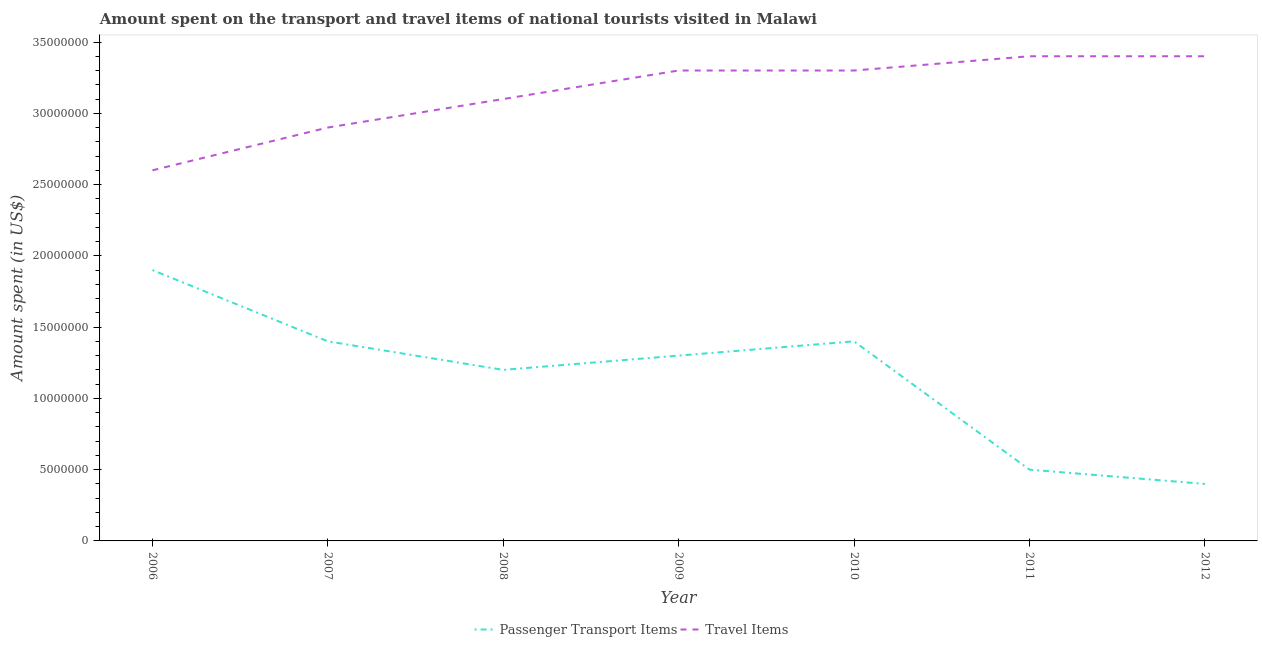Does the line corresponding to amount spent in travel items intersect with the line corresponding to amount spent on passenger transport items?
Offer a terse response. No. What is the amount spent in travel items in 2011?
Your response must be concise. 3.40e+07. Across all years, what is the maximum amount spent in travel items?
Keep it short and to the point. 3.40e+07. Across all years, what is the minimum amount spent on passenger transport items?
Keep it short and to the point. 4.00e+06. In which year was the amount spent in travel items minimum?
Provide a succinct answer. 2006. What is the total amount spent in travel items in the graph?
Your answer should be compact. 2.20e+08. What is the difference between the amount spent on passenger transport items in 2010 and that in 2011?
Provide a succinct answer. 9.00e+06. What is the difference between the amount spent in travel items in 2012 and the amount spent on passenger transport items in 2007?
Your response must be concise. 2.00e+07. What is the average amount spent in travel items per year?
Keep it short and to the point. 3.14e+07. In the year 2009, what is the difference between the amount spent in travel items and amount spent on passenger transport items?
Provide a short and direct response. 2.00e+07. In how many years, is the amount spent in travel items greater than 19000000 US$?
Offer a terse response. 7. What is the ratio of the amount spent in travel items in 2006 to that in 2007?
Ensure brevity in your answer.  0.9. Is the difference between the amount spent in travel items in 2009 and 2010 greater than the difference between the amount spent on passenger transport items in 2009 and 2010?
Your response must be concise. Yes. What is the difference between the highest and the lowest amount spent on passenger transport items?
Ensure brevity in your answer.  1.50e+07. Is the sum of the amount spent in travel items in 2009 and 2012 greater than the maximum amount spent on passenger transport items across all years?
Keep it short and to the point. Yes. Is the amount spent on passenger transport items strictly greater than the amount spent in travel items over the years?
Make the answer very short. No. Is the amount spent in travel items strictly less than the amount spent on passenger transport items over the years?
Ensure brevity in your answer.  No. Are the values on the major ticks of Y-axis written in scientific E-notation?
Your response must be concise. No. Where does the legend appear in the graph?
Provide a short and direct response. Bottom center. How are the legend labels stacked?
Your response must be concise. Horizontal. What is the title of the graph?
Offer a terse response. Amount spent on the transport and travel items of national tourists visited in Malawi. What is the label or title of the Y-axis?
Offer a very short reply. Amount spent (in US$). What is the Amount spent (in US$) in Passenger Transport Items in 2006?
Make the answer very short. 1.90e+07. What is the Amount spent (in US$) of Travel Items in 2006?
Make the answer very short. 2.60e+07. What is the Amount spent (in US$) of Passenger Transport Items in 2007?
Your response must be concise. 1.40e+07. What is the Amount spent (in US$) of Travel Items in 2007?
Offer a terse response. 2.90e+07. What is the Amount spent (in US$) of Passenger Transport Items in 2008?
Provide a succinct answer. 1.20e+07. What is the Amount spent (in US$) of Travel Items in 2008?
Your answer should be very brief. 3.10e+07. What is the Amount spent (in US$) in Passenger Transport Items in 2009?
Give a very brief answer. 1.30e+07. What is the Amount spent (in US$) of Travel Items in 2009?
Keep it short and to the point. 3.30e+07. What is the Amount spent (in US$) in Passenger Transport Items in 2010?
Ensure brevity in your answer.  1.40e+07. What is the Amount spent (in US$) of Travel Items in 2010?
Offer a very short reply. 3.30e+07. What is the Amount spent (in US$) in Travel Items in 2011?
Give a very brief answer. 3.40e+07. What is the Amount spent (in US$) of Travel Items in 2012?
Ensure brevity in your answer.  3.40e+07. Across all years, what is the maximum Amount spent (in US$) of Passenger Transport Items?
Ensure brevity in your answer.  1.90e+07. Across all years, what is the maximum Amount spent (in US$) of Travel Items?
Ensure brevity in your answer.  3.40e+07. Across all years, what is the minimum Amount spent (in US$) of Passenger Transport Items?
Make the answer very short. 4.00e+06. Across all years, what is the minimum Amount spent (in US$) in Travel Items?
Your response must be concise. 2.60e+07. What is the total Amount spent (in US$) in Passenger Transport Items in the graph?
Your answer should be compact. 8.10e+07. What is the total Amount spent (in US$) of Travel Items in the graph?
Your answer should be very brief. 2.20e+08. What is the difference between the Amount spent (in US$) in Travel Items in 2006 and that in 2007?
Your answer should be compact. -3.00e+06. What is the difference between the Amount spent (in US$) of Passenger Transport Items in 2006 and that in 2008?
Make the answer very short. 7.00e+06. What is the difference between the Amount spent (in US$) in Travel Items in 2006 and that in 2008?
Your answer should be compact. -5.00e+06. What is the difference between the Amount spent (in US$) in Travel Items in 2006 and that in 2009?
Provide a short and direct response. -7.00e+06. What is the difference between the Amount spent (in US$) in Travel Items in 2006 and that in 2010?
Offer a terse response. -7.00e+06. What is the difference between the Amount spent (in US$) of Passenger Transport Items in 2006 and that in 2011?
Your answer should be compact. 1.40e+07. What is the difference between the Amount spent (in US$) in Travel Items in 2006 and that in 2011?
Keep it short and to the point. -8.00e+06. What is the difference between the Amount spent (in US$) in Passenger Transport Items in 2006 and that in 2012?
Make the answer very short. 1.50e+07. What is the difference between the Amount spent (in US$) of Travel Items in 2006 and that in 2012?
Your response must be concise. -8.00e+06. What is the difference between the Amount spent (in US$) of Passenger Transport Items in 2007 and that in 2009?
Your answer should be very brief. 1.00e+06. What is the difference between the Amount spent (in US$) of Travel Items in 2007 and that in 2009?
Provide a succinct answer. -4.00e+06. What is the difference between the Amount spent (in US$) of Passenger Transport Items in 2007 and that in 2010?
Provide a short and direct response. 0. What is the difference between the Amount spent (in US$) in Passenger Transport Items in 2007 and that in 2011?
Provide a succinct answer. 9.00e+06. What is the difference between the Amount spent (in US$) in Travel Items in 2007 and that in 2011?
Keep it short and to the point. -5.00e+06. What is the difference between the Amount spent (in US$) of Travel Items in 2007 and that in 2012?
Provide a succinct answer. -5.00e+06. What is the difference between the Amount spent (in US$) of Passenger Transport Items in 2008 and that in 2010?
Your answer should be very brief. -2.00e+06. What is the difference between the Amount spent (in US$) of Passenger Transport Items in 2008 and that in 2011?
Your answer should be very brief. 7.00e+06. What is the difference between the Amount spent (in US$) in Travel Items in 2008 and that in 2011?
Ensure brevity in your answer.  -3.00e+06. What is the difference between the Amount spent (in US$) in Passenger Transport Items in 2008 and that in 2012?
Ensure brevity in your answer.  8.00e+06. What is the difference between the Amount spent (in US$) in Travel Items in 2009 and that in 2010?
Provide a succinct answer. 0. What is the difference between the Amount spent (in US$) of Passenger Transport Items in 2009 and that in 2011?
Offer a very short reply. 8.00e+06. What is the difference between the Amount spent (in US$) in Passenger Transport Items in 2009 and that in 2012?
Give a very brief answer. 9.00e+06. What is the difference between the Amount spent (in US$) of Passenger Transport Items in 2010 and that in 2011?
Provide a short and direct response. 9.00e+06. What is the difference between the Amount spent (in US$) in Travel Items in 2010 and that in 2011?
Offer a very short reply. -1.00e+06. What is the difference between the Amount spent (in US$) of Travel Items in 2010 and that in 2012?
Give a very brief answer. -1.00e+06. What is the difference between the Amount spent (in US$) of Travel Items in 2011 and that in 2012?
Give a very brief answer. 0. What is the difference between the Amount spent (in US$) in Passenger Transport Items in 2006 and the Amount spent (in US$) in Travel Items in 2007?
Your response must be concise. -1.00e+07. What is the difference between the Amount spent (in US$) in Passenger Transport Items in 2006 and the Amount spent (in US$) in Travel Items in 2008?
Your answer should be very brief. -1.20e+07. What is the difference between the Amount spent (in US$) in Passenger Transport Items in 2006 and the Amount spent (in US$) in Travel Items in 2009?
Give a very brief answer. -1.40e+07. What is the difference between the Amount spent (in US$) of Passenger Transport Items in 2006 and the Amount spent (in US$) of Travel Items in 2010?
Your response must be concise. -1.40e+07. What is the difference between the Amount spent (in US$) in Passenger Transport Items in 2006 and the Amount spent (in US$) in Travel Items in 2011?
Your response must be concise. -1.50e+07. What is the difference between the Amount spent (in US$) in Passenger Transport Items in 2006 and the Amount spent (in US$) in Travel Items in 2012?
Your answer should be very brief. -1.50e+07. What is the difference between the Amount spent (in US$) of Passenger Transport Items in 2007 and the Amount spent (in US$) of Travel Items in 2008?
Your response must be concise. -1.70e+07. What is the difference between the Amount spent (in US$) of Passenger Transport Items in 2007 and the Amount spent (in US$) of Travel Items in 2009?
Keep it short and to the point. -1.90e+07. What is the difference between the Amount spent (in US$) in Passenger Transport Items in 2007 and the Amount spent (in US$) in Travel Items in 2010?
Your answer should be very brief. -1.90e+07. What is the difference between the Amount spent (in US$) of Passenger Transport Items in 2007 and the Amount spent (in US$) of Travel Items in 2011?
Offer a very short reply. -2.00e+07. What is the difference between the Amount spent (in US$) of Passenger Transport Items in 2007 and the Amount spent (in US$) of Travel Items in 2012?
Make the answer very short. -2.00e+07. What is the difference between the Amount spent (in US$) of Passenger Transport Items in 2008 and the Amount spent (in US$) of Travel Items in 2009?
Offer a terse response. -2.10e+07. What is the difference between the Amount spent (in US$) of Passenger Transport Items in 2008 and the Amount spent (in US$) of Travel Items in 2010?
Offer a terse response. -2.10e+07. What is the difference between the Amount spent (in US$) in Passenger Transport Items in 2008 and the Amount spent (in US$) in Travel Items in 2011?
Offer a terse response. -2.20e+07. What is the difference between the Amount spent (in US$) in Passenger Transport Items in 2008 and the Amount spent (in US$) in Travel Items in 2012?
Your response must be concise. -2.20e+07. What is the difference between the Amount spent (in US$) in Passenger Transport Items in 2009 and the Amount spent (in US$) in Travel Items in 2010?
Keep it short and to the point. -2.00e+07. What is the difference between the Amount spent (in US$) in Passenger Transport Items in 2009 and the Amount spent (in US$) in Travel Items in 2011?
Offer a very short reply. -2.10e+07. What is the difference between the Amount spent (in US$) in Passenger Transport Items in 2009 and the Amount spent (in US$) in Travel Items in 2012?
Your answer should be compact. -2.10e+07. What is the difference between the Amount spent (in US$) in Passenger Transport Items in 2010 and the Amount spent (in US$) in Travel Items in 2011?
Ensure brevity in your answer.  -2.00e+07. What is the difference between the Amount spent (in US$) in Passenger Transport Items in 2010 and the Amount spent (in US$) in Travel Items in 2012?
Make the answer very short. -2.00e+07. What is the difference between the Amount spent (in US$) of Passenger Transport Items in 2011 and the Amount spent (in US$) of Travel Items in 2012?
Your answer should be compact. -2.90e+07. What is the average Amount spent (in US$) of Passenger Transport Items per year?
Ensure brevity in your answer.  1.16e+07. What is the average Amount spent (in US$) in Travel Items per year?
Offer a very short reply. 3.14e+07. In the year 2006, what is the difference between the Amount spent (in US$) in Passenger Transport Items and Amount spent (in US$) in Travel Items?
Provide a succinct answer. -7.00e+06. In the year 2007, what is the difference between the Amount spent (in US$) of Passenger Transport Items and Amount spent (in US$) of Travel Items?
Offer a terse response. -1.50e+07. In the year 2008, what is the difference between the Amount spent (in US$) of Passenger Transport Items and Amount spent (in US$) of Travel Items?
Give a very brief answer. -1.90e+07. In the year 2009, what is the difference between the Amount spent (in US$) of Passenger Transport Items and Amount spent (in US$) of Travel Items?
Ensure brevity in your answer.  -2.00e+07. In the year 2010, what is the difference between the Amount spent (in US$) of Passenger Transport Items and Amount spent (in US$) of Travel Items?
Offer a very short reply. -1.90e+07. In the year 2011, what is the difference between the Amount spent (in US$) of Passenger Transport Items and Amount spent (in US$) of Travel Items?
Your answer should be very brief. -2.90e+07. In the year 2012, what is the difference between the Amount spent (in US$) of Passenger Transport Items and Amount spent (in US$) of Travel Items?
Provide a succinct answer. -3.00e+07. What is the ratio of the Amount spent (in US$) in Passenger Transport Items in 2006 to that in 2007?
Ensure brevity in your answer.  1.36. What is the ratio of the Amount spent (in US$) in Travel Items in 2006 to that in 2007?
Keep it short and to the point. 0.9. What is the ratio of the Amount spent (in US$) in Passenger Transport Items in 2006 to that in 2008?
Ensure brevity in your answer.  1.58. What is the ratio of the Amount spent (in US$) of Travel Items in 2006 to that in 2008?
Your answer should be compact. 0.84. What is the ratio of the Amount spent (in US$) of Passenger Transport Items in 2006 to that in 2009?
Give a very brief answer. 1.46. What is the ratio of the Amount spent (in US$) in Travel Items in 2006 to that in 2009?
Give a very brief answer. 0.79. What is the ratio of the Amount spent (in US$) of Passenger Transport Items in 2006 to that in 2010?
Provide a short and direct response. 1.36. What is the ratio of the Amount spent (in US$) of Travel Items in 2006 to that in 2010?
Your response must be concise. 0.79. What is the ratio of the Amount spent (in US$) of Passenger Transport Items in 2006 to that in 2011?
Make the answer very short. 3.8. What is the ratio of the Amount spent (in US$) of Travel Items in 2006 to that in 2011?
Your response must be concise. 0.76. What is the ratio of the Amount spent (in US$) of Passenger Transport Items in 2006 to that in 2012?
Make the answer very short. 4.75. What is the ratio of the Amount spent (in US$) in Travel Items in 2006 to that in 2012?
Keep it short and to the point. 0.76. What is the ratio of the Amount spent (in US$) of Travel Items in 2007 to that in 2008?
Keep it short and to the point. 0.94. What is the ratio of the Amount spent (in US$) in Travel Items in 2007 to that in 2009?
Your response must be concise. 0.88. What is the ratio of the Amount spent (in US$) of Passenger Transport Items in 2007 to that in 2010?
Make the answer very short. 1. What is the ratio of the Amount spent (in US$) of Travel Items in 2007 to that in 2010?
Offer a terse response. 0.88. What is the ratio of the Amount spent (in US$) of Travel Items in 2007 to that in 2011?
Keep it short and to the point. 0.85. What is the ratio of the Amount spent (in US$) of Passenger Transport Items in 2007 to that in 2012?
Provide a succinct answer. 3.5. What is the ratio of the Amount spent (in US$) in Travel Items in 2007 to that in 2012?
Offer a terse response. 0.85. What is the ratio of the Amount spent (in US$) in Travel Items in 2008 to that in 2009?
Provide a succinct answer. 0.94. What is the ratio of the Amount spent (in US$) in Travel Items in 2008 to that in 2010?
Keep it short and to the point. 0.94. What is the ratio of the Amount spent (in US$) in Passenger Transport Items in 2008 to that in 2011?
Give a very brief answer. 2.4. What is the ratio of the Amount spent (in US$) of Travel Items in 2008 to that in 2011?
Make the answer very short. 0.91. What is the ratio of the Amount spent (in US$) of Passenger Transport Items in 2008 to that in 2012?
Your answer should be compact. 3. What is the ratio of the Amount spent (in US$) of Travel Items in 2008 to that in 2012?
Ensure brevity in your answer.  0.91. What is the ratio of the Amount spent (in US$) of Travel Items in 2009 to that in 2011?
Provide a short and direct response. 0.97. What is the ratio of the Amount spent (in US$) of Travel Items in 2009 to that in 2012?
Your answer should be very brief. 0.97. What is the ratio of the Amount spent (in US$) in Passenger Transport Items in 2010 to that in 2011?
Provide a short and direct response. 2.8. What is the ratio of the Amount spent (in US$) in Travel Items in 2010 to that in 2011?
Offer a terse response. 0.97. What is the ratio of the Amount spent (in US$) of Travel Items in 2010 to that in 2012?
Offer a very short reply. 0.97. What is the ratio of the Amount spent (in US$) in Passenger Transport Items in 2011 to that in 2012?
Offer a terse response. 1.25. What is the difference between the highest and the second highest Amount spent (in US$) of Passenger Transport Items?
Ensure brevity in your answer.  5.00e+06. What is the difference between the highest and the second highest Amount spent (in US$) of Travel Items?
Your response must be concise. 0. What is the difference between the highest and the lowest Amount spent (in US$) of Passenger Transport Items?
Your answer should be very brief. 1.50e+07. What is the difference between the highest and the lowest Amount spent (in US$) in Travel Items?
Give a very brief answer. 8.00e+06. 